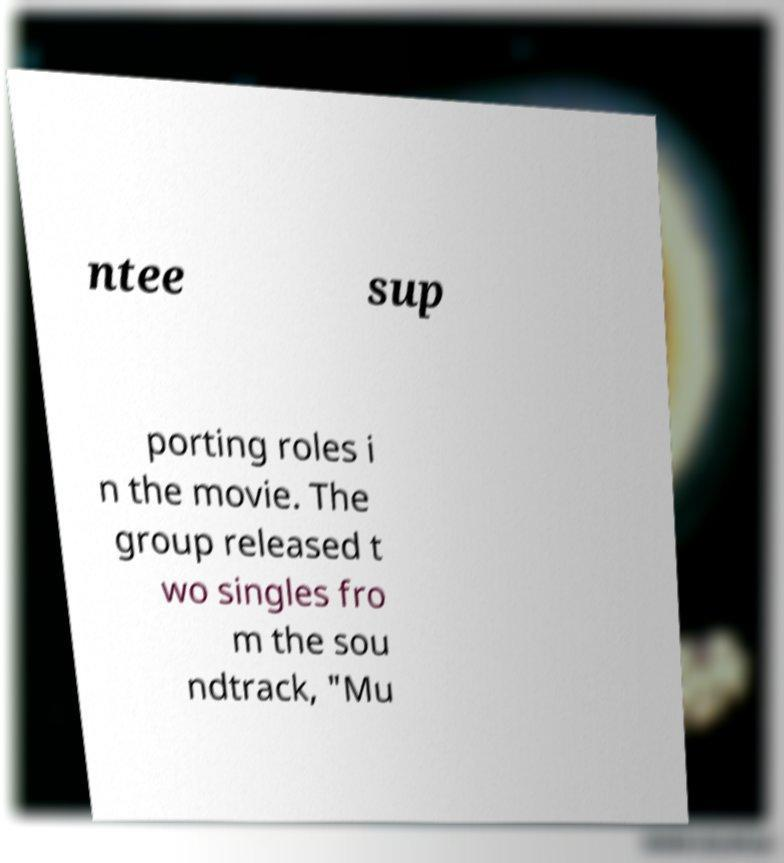There's text embedded in this image that I need extracted. Can you transcribe it verbatim? ntee sup porting roles i n the movie. The group released t wo singles fro m the sou ndtrack, "Mu 